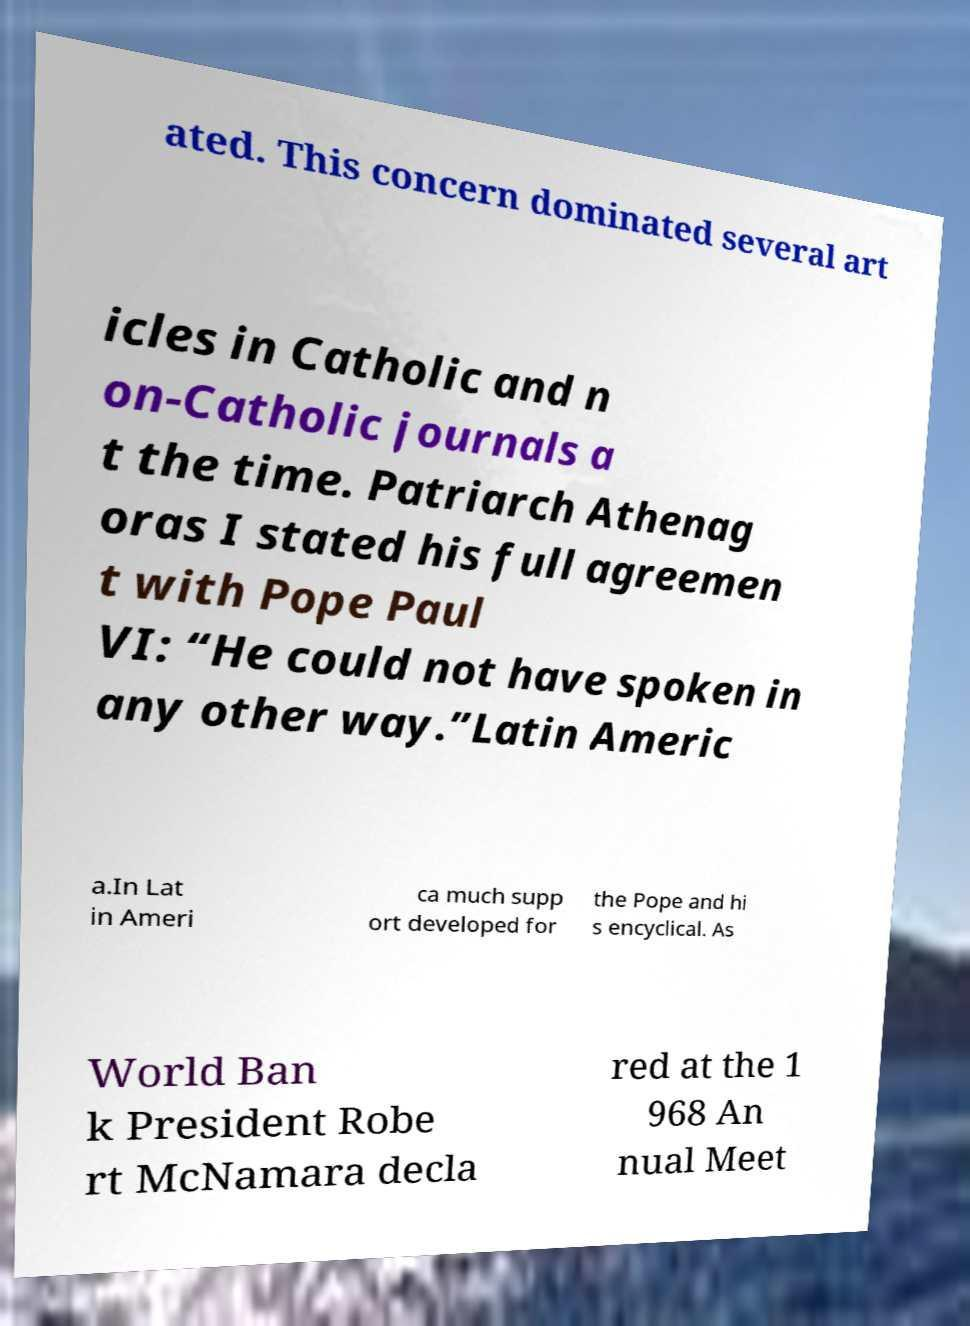Can you read and provide the text displayed in the image?This photo seems to have some interesting text. Can you extract and type it out for me? ated. This concern dominated several art icles in Catholic and n on-Catholic journals a t the time. Patriarch Athenag oras I stated his full agreemen t with Pope Paul VI: “He could not have spoken in any other way.”Latin Americ a.In Lat in Ameri ca much supp ort developed for the Pope and hi s encyclical. As World Ban k President Robe rt McNamara decla red at the 1 968 An nual Meet 